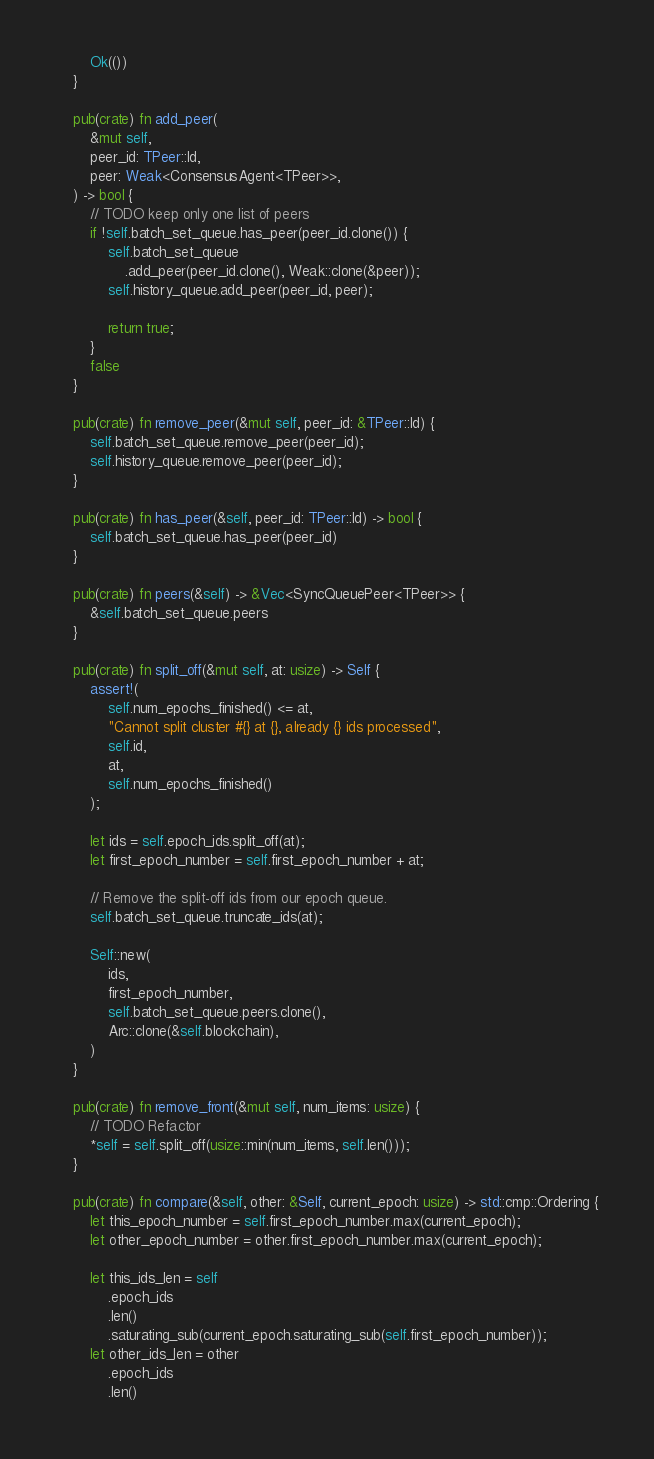Convert code to text. <code><loc_0><loc_0><loc_500><loc_500><_Rust_>        Ok(())
    }

    pub(crate) fn add_peer(
        &mut self,
        peer_id: TPeer::Id,
        peer: Weak<ConsensusAgent<TPeer>>,
    ) -> bool {
        // TODO keep only one list of peers
        if !self.batch_set_queue.has_peer(peer_id.clone()) {
            self.batch_set_queue
                .add_peer(peer_id.clone(), Weak::clone(&peer));
            self.history_queue.add_peer(peer_id, peer);

            return true;
        }
        false
    }

    pub(crate) fn remove_peer(&mut self, peer_id: &TPeer::Id) {
        self.batch_set_queue.remove_peer(peer_id);
        self.history_queue.remove_peer(peer_id);
    }

    pub(crate) fn has_peer(&self, peer_id: TPeer::Id) -> bool {
        self.batch_set_queue.has_peer(peer_id)
    }

    pub(crate) fn peers(&self) -> &Vec<SyncQueuePeer<TPeer>> {
        &self.batch_set_queue.peers
    }

    pub(crate) fn split_off(&mut self, at: usize) -> Self {
        assert!(
            self.num_epochs_finished() <= at,
            "Cannot split cluster #{} at {}, already {} ids processed",
            self.id,
            at,
            self.num_epochs_finished()
        );

        let ids = self.epoch_ids.split_off(at);
        let first_epoch_number = self.first_epoch_number + at;

        // Remove the split-off ids from our epoch queue.
        self.batch_set_queue.truncate_ids(at);

        Self::new(
            ids,
            first_epoch_number,
            self.batch_set_queue.peers.clone(),
            Arc::clone(&self.blockchain),
        )
    }

    pub(crate) fn remove_front(&mut self, num_items: usize) {
        // TODO Refactor
        *self = self.split_off(usize::min(num_items, self.len()));
    }

    pub(crate) fn compare(&self, other: &Self, current_epoch: usize) -> std::cmp::Ordering {
        let this_epoch_number = self.first_epoch_number.max(current_epoch);
        let other_epoch_number = other.first_epoch_number.max(current_epoch);

        let this_ids_len = self
            .epoch_ids
            .len()
            .saturating_sub(current_epoch.saturating_sub(self.first_epoch_number));
        let other_ids_len = other
            .epoch_ids
            .len()</code> 